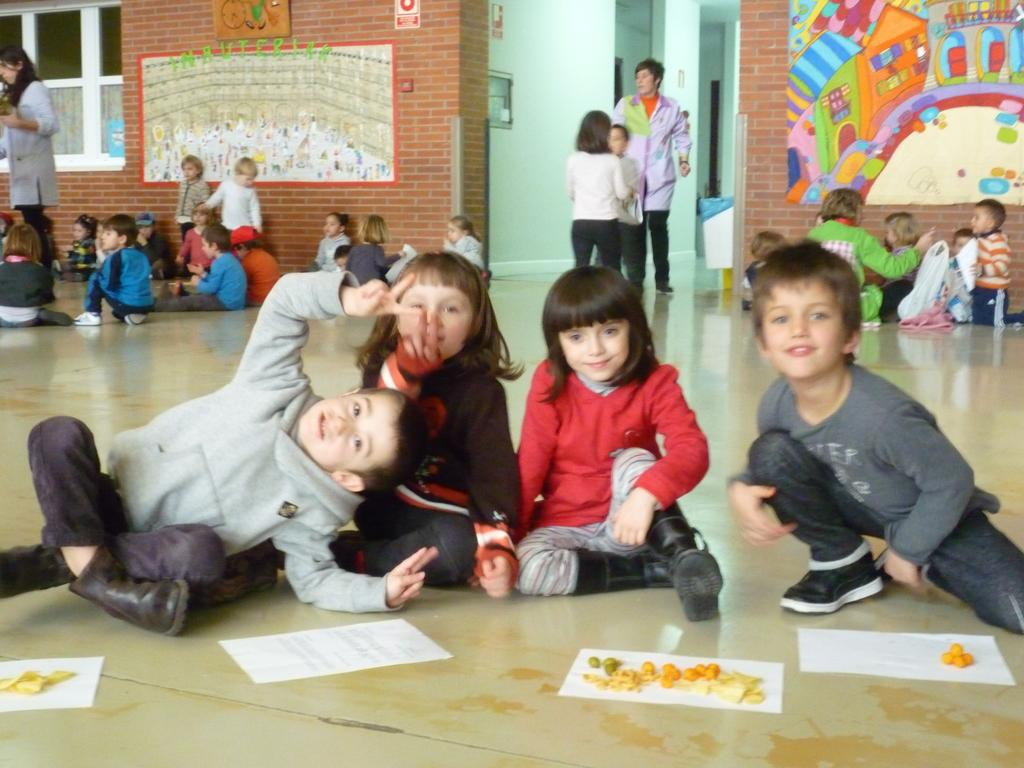What is happening on the floor in the image? There are kids on the floor in the image. What is written or drawn on the paper in the image? There is something on a paper in the image. What can be seen on the wall in the background of the image? There are paintings on the wall in the background of the image. What year is depicted in the painting on the wall in the image? There is no specific year depicted in the painting on the wall in the image. Can you see any roses in the image? There are no roses present in the image. 